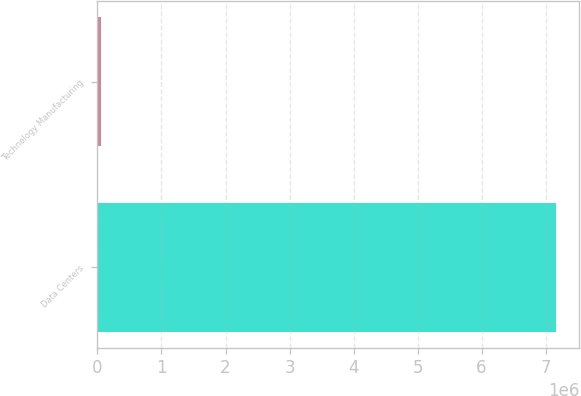Convert chart. <chart><loc_0><loc_0><loc_500><loc_500><bar_chart><fcel>Data Centers<fcel>Technology Manufacturing<nl><fcel>7.1676e+06<fcel>61024<nl></chart> 